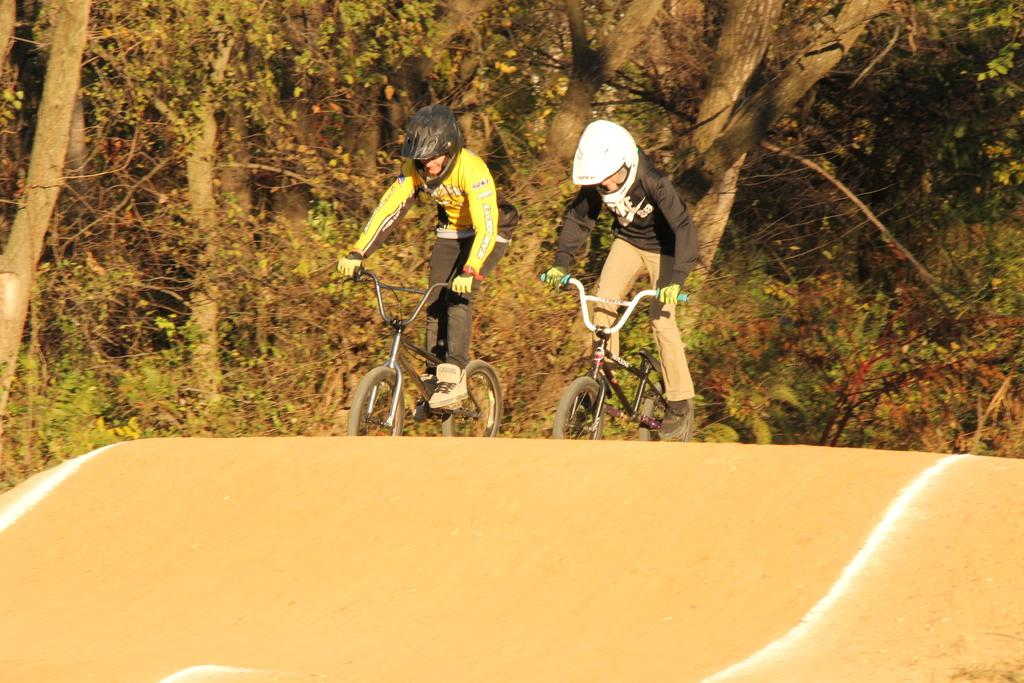How many people are in the image? There are two persons in the image. What are the persons doing in the image? The persons are riding bicycles. What can be seen in the background of the image? There are trees visible in the background. What type of road is at the bottom of the image? There is a mud road at the bottom of the image. Where are the dolls located in the image? There are no dolls present in the image. Can you see a harbor in the image? There is no harbor visible in the image. 